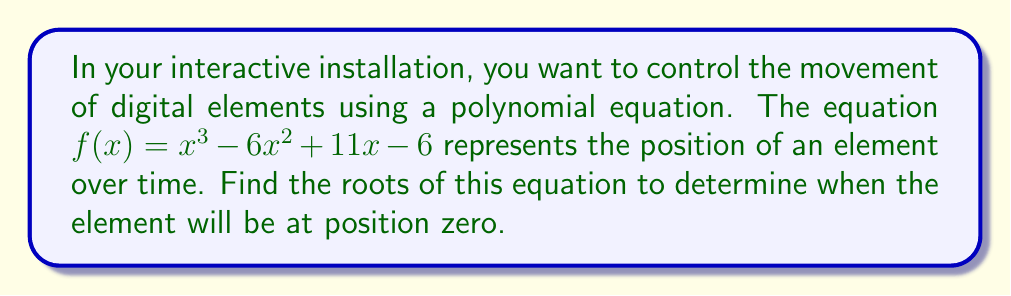Provide a solution to this math problem. To find the roots of the polynomial equation $f(x) = x^3 - 6x^2 + 11x - 6$, we need to factor it and solve for $x$ when $f(x) = 0$.

1) First, let's check if there are any rational roots using the rational root theorem. The possible rational roots are the factors of the constant term: $\pm1, \pm2, \pm3, \pm6$.

2) Testing these values, we find that $f(1) = 0$. So, $(x-1)$ is a factor.

3) We can use polynomial long division to divide $f(x)$ by $(x-1)$:

   $x^3 - 6x^2 + 11x - 6 = (x-1)(x^2 - 5x + 6)$

4) Now we need to factor the quadratic term $x^2 - 5x + 6$:
   
   $x^2 - 5x + 6 = (x-2)(x-3)$

5) Therefore, the fully factored polynomial is:

   $f(x) = (x-1)(x-2)(x-3)$

6) The roots of the polynomial are the values of $x$ that make each factor equal to zero:

   $x-1 = 0$, $x = 1$
   $x-2 = 0$, $x = 2$
   $x-3 = 0$, $x = 3$

These roots represent the times when the digital element will be at position zero in your installation.
Answer: The roots of the polynomial equation $f(x) = x^3 - 6x^2 + 11x - 6$ are $x = 1$, $x = 2$, and $x = 3$. 